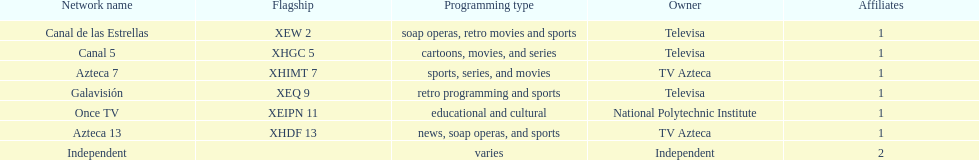What is the number of affiliates associated with galavision? 1. 